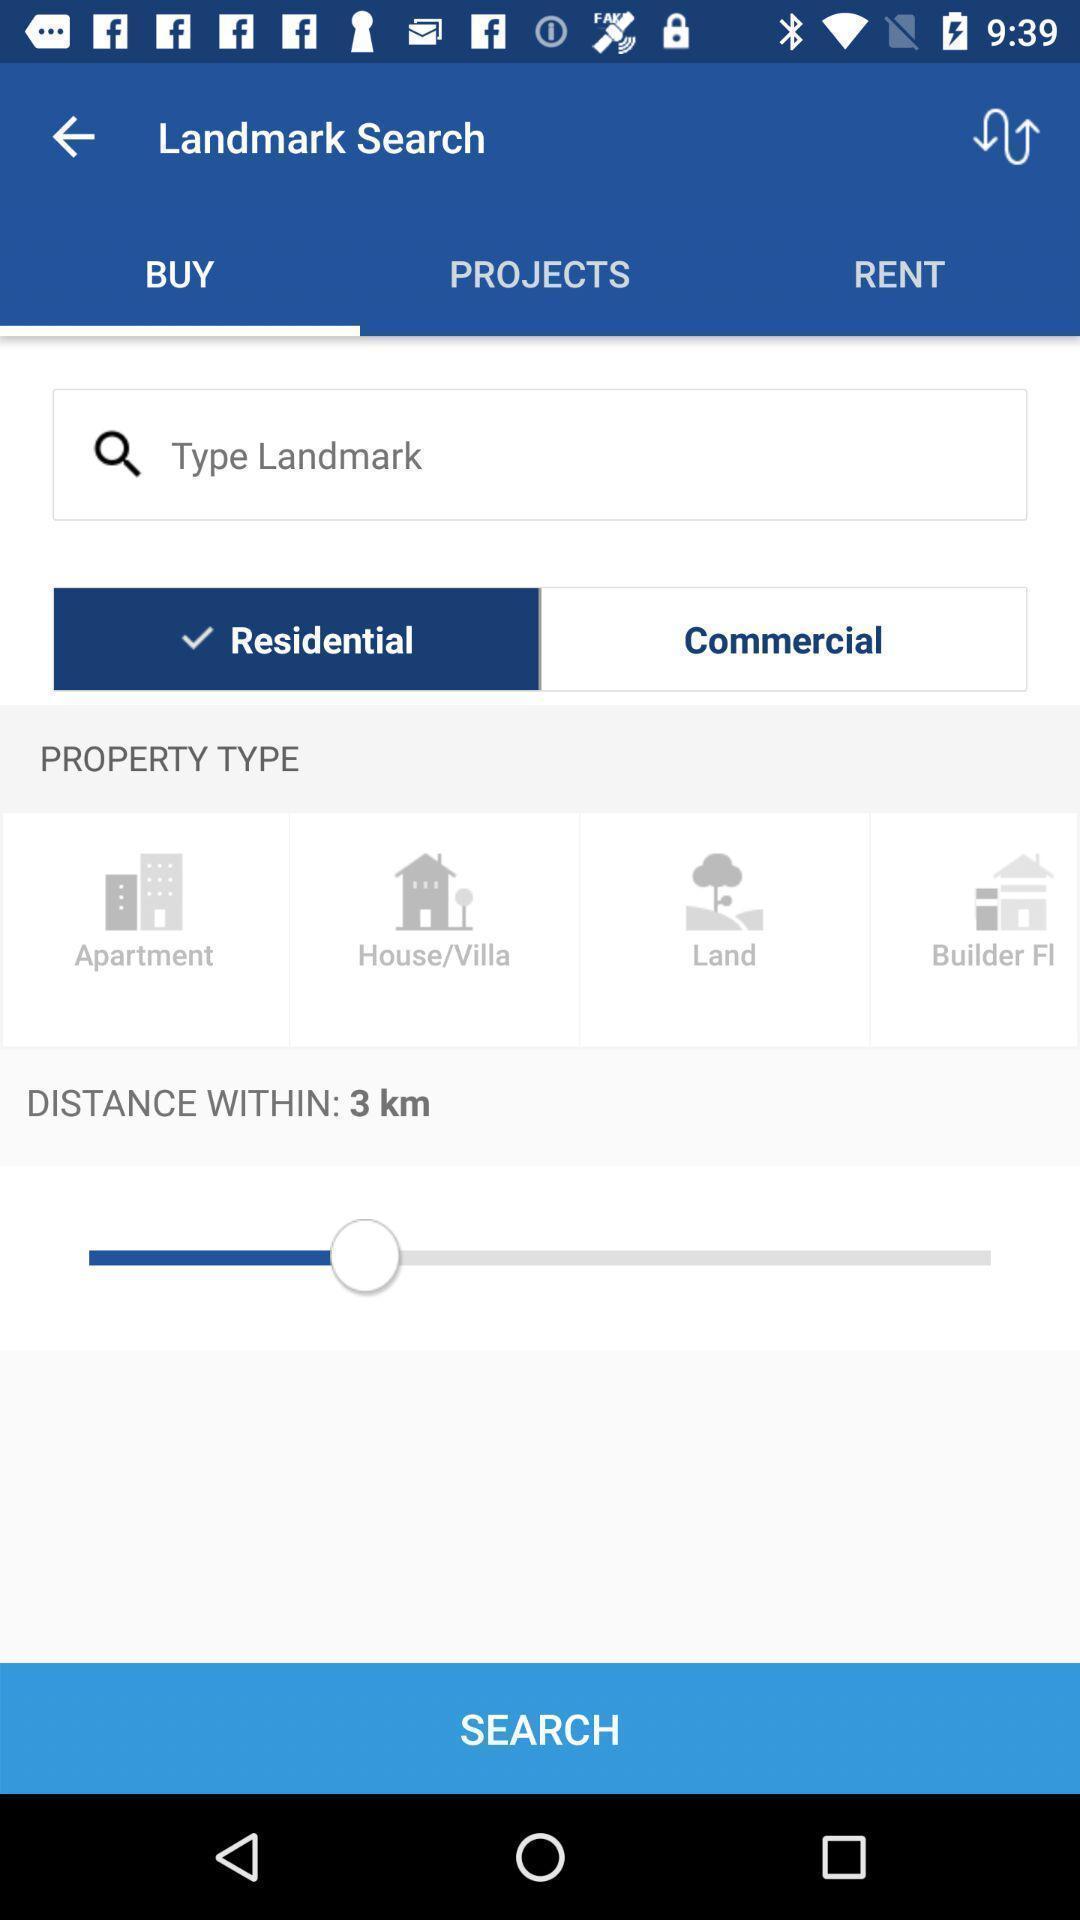Summarize the main components in this picture. Screen displaying the page to search landmark. 